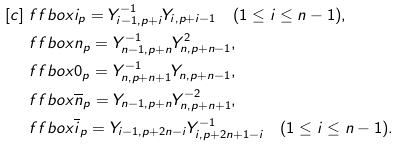<formula> <loc_0><loc_0><loc_500><loc_500>[ c ] & \ f f b o x { i } _ { p } = Y _ { i - 1 , p + i } ^ { - 1 } Y _ { i , p + { i - 1 } } \quad ( 1 \leq i \leq n - 1 ) , \\ & \ f f b o x { n } _ { p } = Y _ { n - 1 , p + n } ^ { - 1 } Y _ { n , p + { n - 1 } } ^ { 2 } , \\ & \ f f b o x { 0 } _ { p } = Y _ { n , p + { n } + 1 } ^ { - 1 } Y _ { n , p + { n - 1 } } , \\ & \ f f b o x { \overline { n } } _ { p } = Y _ { n - 1 , p + n } Y _ { n , p + { n } + 1 } ^ { - 2 } , \\ & \ f f b o x { \overline { i } } _ { p } = Y _ { i - 1 , p + { 2 n - i } } Y _ { i , p + { 2 n + 1 - i } } ^ { - 1 } \quad ( 1 \leq i \leq n - 1 ) .</formula> 